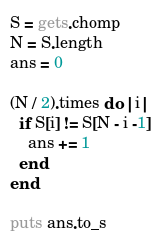<code> <loc_0><loc_0><loc_500><loc_500><_Ruby_>S = gets.chomp
N = S.length
ans = 0

(N / 2).times do |i|
  if S[i] != S[N - i -1]
    ans += 1
  end
end

puts ans.to_s</code> 